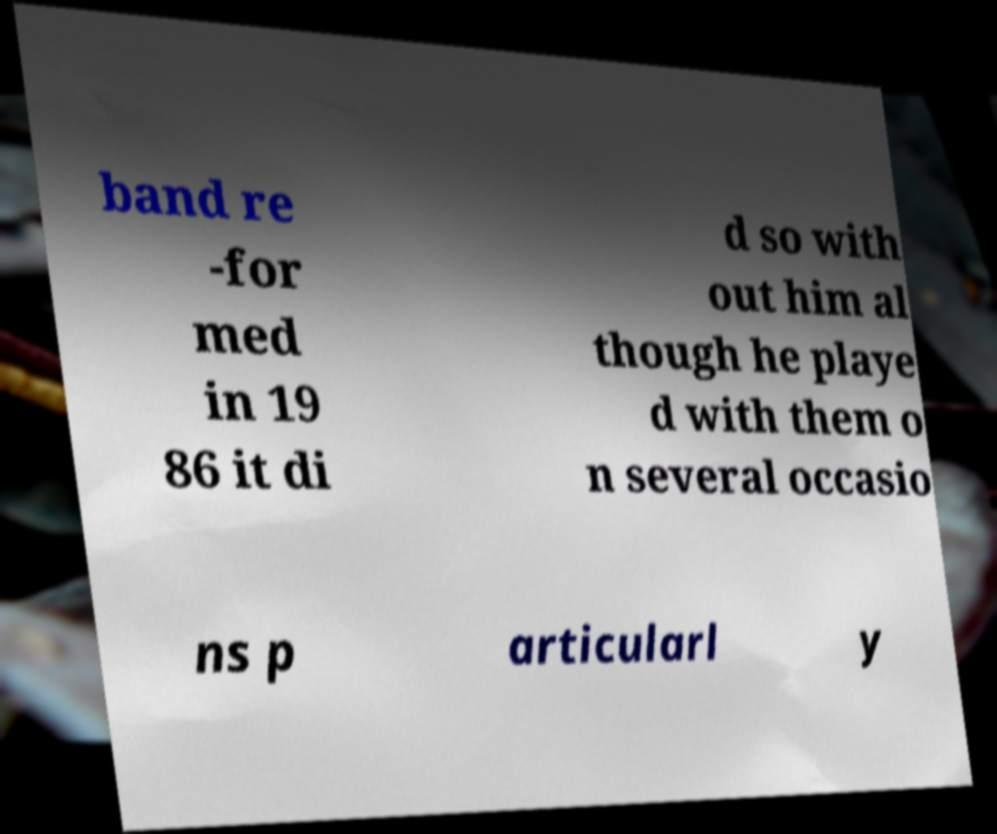Can you read and provide the text displayed in the image?This photo seems to have some interesting text. Can you extract and type it out for me? band re -for med in 19 86 it di d so with out him al though he playe d with them o n several occasio ns p articularl y 